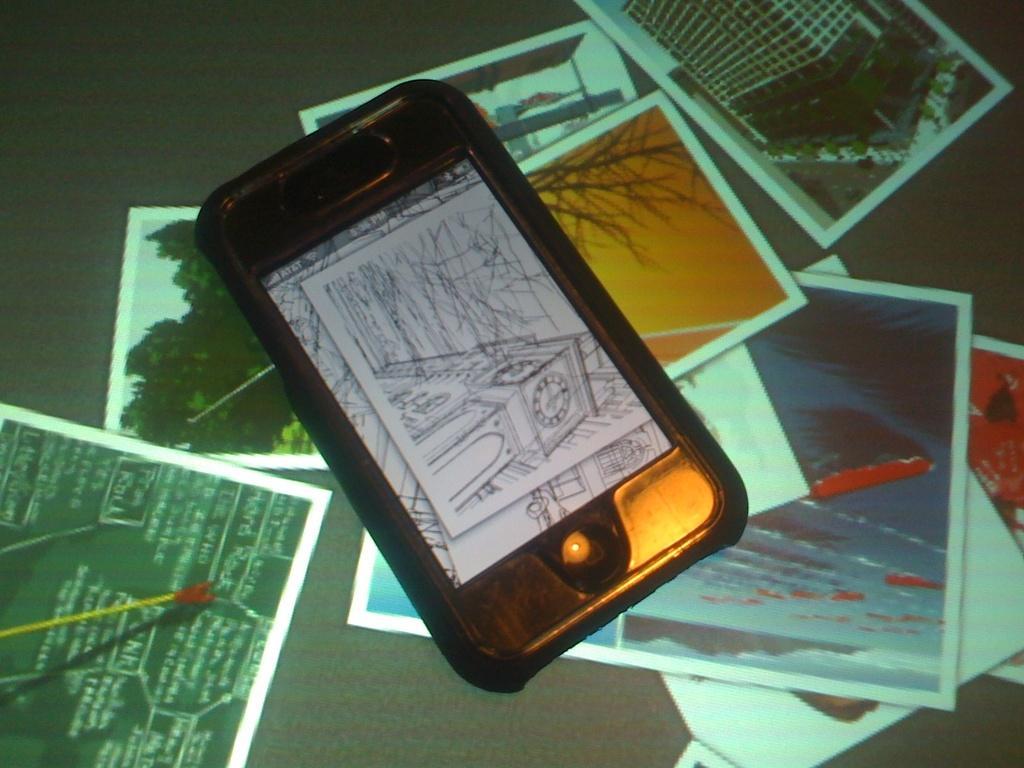In one or two sentences, can you explain what this image depicts? In this image we can see different photographs, and there is a mobile on it and we can some images in the mobile. 